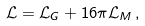<formula> <loc_0><loc_0><loc_500><loc_500>\mathcal { L } = \mathcal { L } _ { G } + 1 6 \pi \mathcal { L } _ { M } \, ,</formula> 